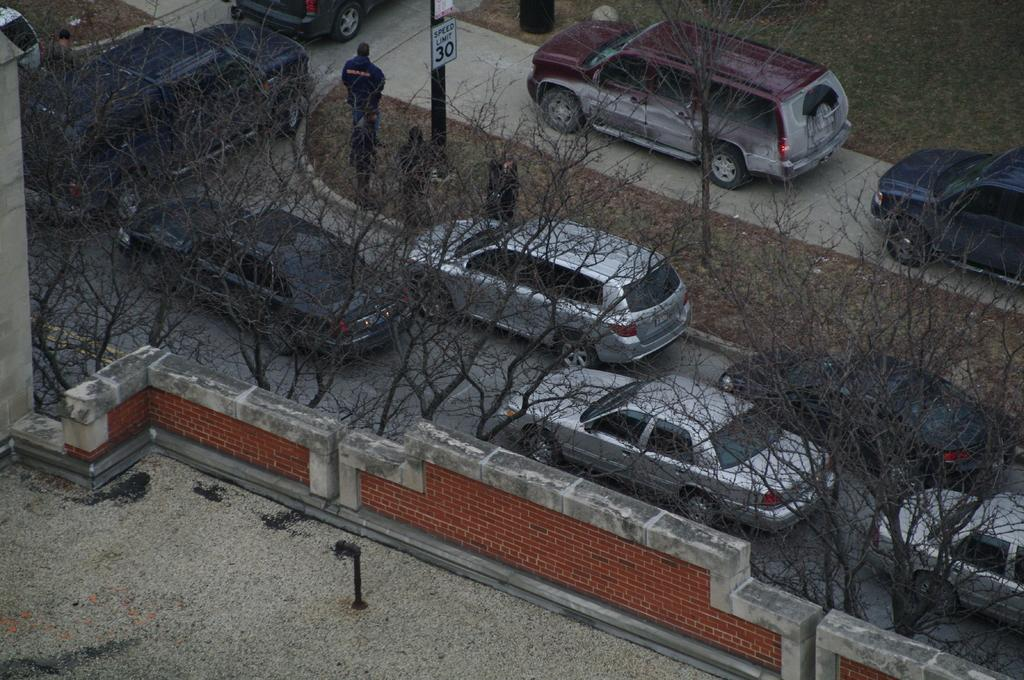What type of surface is visible at the bottom of the image? There is a floor in the image. What can be seen on the sides of the image? There is a wall in the image. What are the vehicles parked on in the image? Cars are parked on the road in the image. What type of vegetation is present in the image? Trees are present in the image. Who or what can be seen in the image besides the floor, wall, cars, and trees? People are visible in the image. Reasoning: Let's let's think step by step in order to produce the conversation. We start by identifying the main subjects and objects in the image based on the provided facts. We then formulate questions that focus on the location and characteristics of these subjects and objects, ensuring that each question can be answered definitively with the information given. We avoid yes/no questions and ensure that the language is simple and clear. Absurd Question/Answer: What is the digestion process of the trees in the image? There is no digestion process for trees in the image, as they are not living organisms. What type of laborer is working on the wall in the image? There is no laborer working on the wall in the image; it is a static structure. How fast are the people running in the image? There is no indication of anyone running in the image; people are visible, but their actions are not specified. 